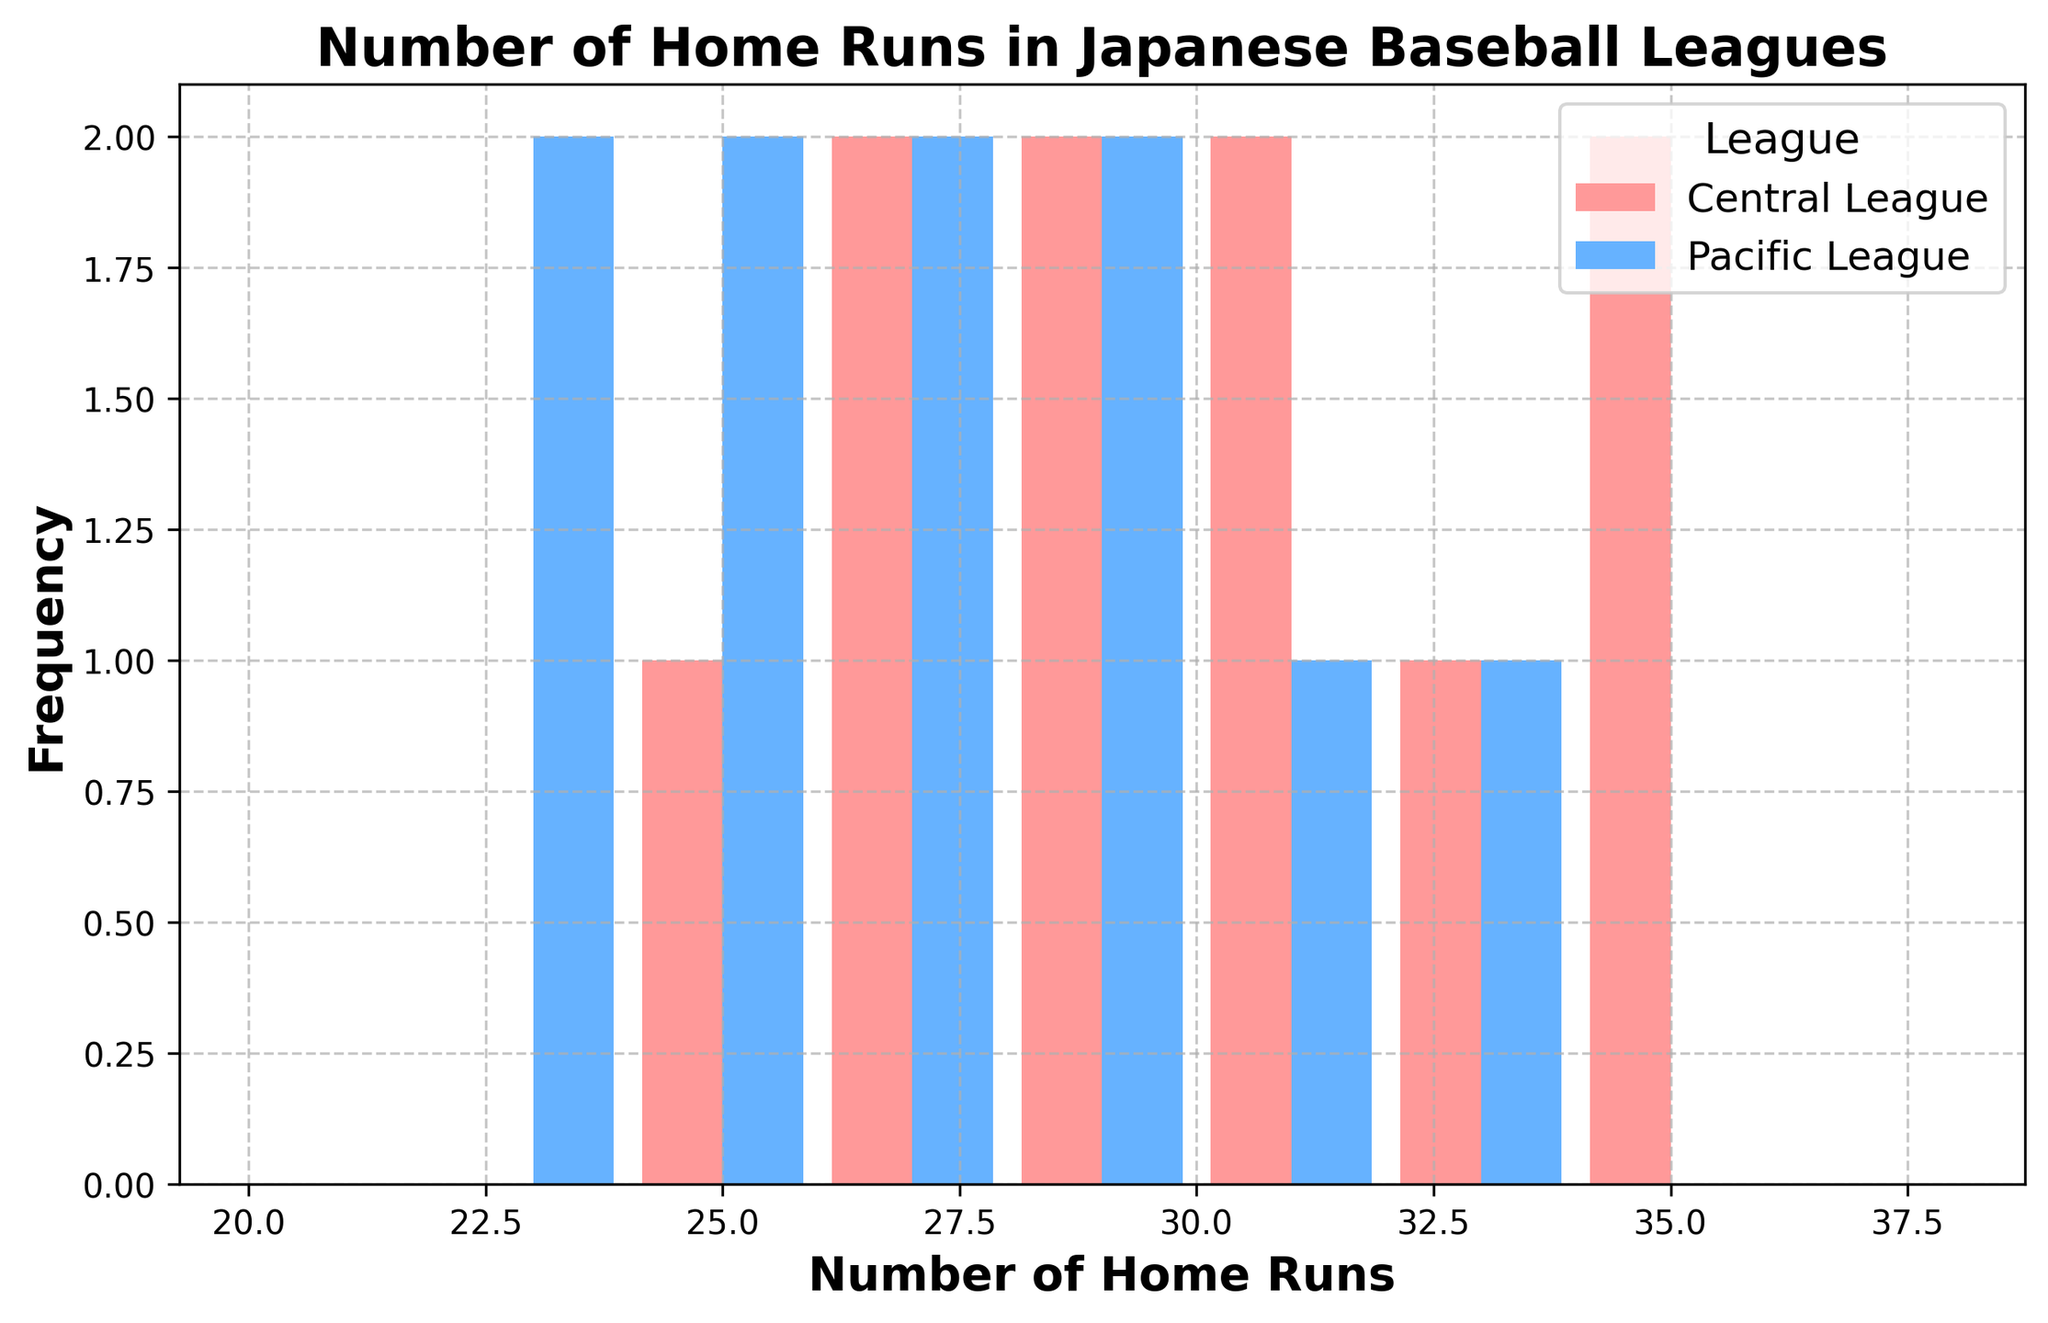What's the most common number of home runs hit in the Central League? We need to look at the frequency of each bin in the histogram for the Central League bars (which are in red). The highest bar indicates the most common number of home runs.
Answer: 30-32 Which league has the highest frequency for any given bin? We need to compare the height of all the bins from both Central League (red bars) and Pacific League (blue bars). The tallest bar overall determines the highest frequency.
Answer: Central League What is the average number of home runs hit in the Central League? We sum the values for the Central League and then divide by the number of data points: (25+30+27+34+28+29+33+31+26+35)/10 = 298/10 = 29.8.
Answer: 29.8 Compare the number of home runs hit between Central League and Pacific League in the range of 24 to 26. Which league has more? We look at the histogram bins corresponding to 24-26 and check the height of red bars (Central) and blue bars (Pacific). In that range, the blue bars are higher.
Answer: Pacific League What is the least common number of home runs hit in the Pacific League? We identify the smallest bar among the Pacific League bins (blue bars) to find the lowest frequency.
Answer: 32 How many more home runs are hit in the highest bin for the Central League compared to the Pacific League? Identify the highest bin for Central League (red) and Pacific League (blue). Compare their frequencies. For the bin 30-32, Central League has a higher frequency. The difference in their heights needs to be calculated.
Answer: 1 Describe the overall distribution pattern for the Pacific League. By observing the blue bars, note the distribution. The home runs are distributed relatively evenly, with no extremely high frequencies observed.
Answer: Even distribution Which league has a wider spread of home runs hit based on the histogram? We assess the range covered by the bars for both Central League (red) and Pacific League (blue). The league with the wider spread has bars further apart.
Answer: Central League In the histogram, which bin range shows an equal number of home runs hit for both leagues? Identify a bin in the histogram where both red and blue bars have the same (or very close) height.
Answer: 26-28 